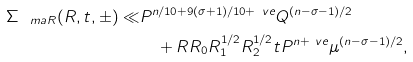Convert formula to latex. <formula><loc_0><loc_0><loc_500><loc_500>\Sigma _ { \ m a { R } } ( R , t , \pm ) \ll & P ^ { n / 1 0 + 9 ( \sigma + 1 ) / 1 0 + \ v e } Q ^ { ( n - \sigma - 1 ) / 2 } \\ & \quad + R R _ { 0 } R _ { 1 } ^ { 1 / 2 } R _ { 2 } ^ { 1 / 2 } t P ^ { n + \ v e } \mu ^ { ( n - \sigma - 1 ) / 2 } ,</formula> 